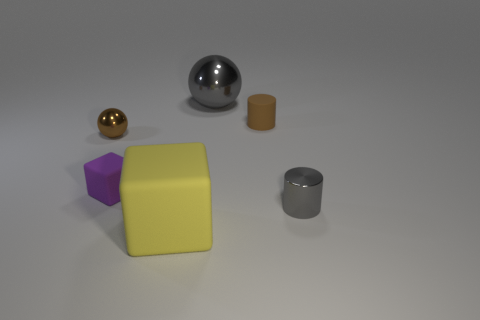What number of metallic spheres have the same size as the purple rubber block?
Ensure brevity in your answer.  1. What number of small gray metallic cylinders are behind the tiny purple block that is left of the large gray ball?
Give a very brief answer. 0. Is the color of the metallic object that is left of the big yellow matte cube the same as the large block?
Keep it short and to the point. No. There is a gray metallic object that is behind the cube that is behind the small gray metallic thing; is there a tiny object left of it?
Provide a short and direct response. Yes. There is a shiny object that is both behind the tiny block and to the right of the purple object; what is its shape?
Your response must be concise. Sphere. Is there a small matte block that has the same color as the large cube?
Provide a short and direct response. No. The ball that is right of the rubber block that is in front of the shiny cylinder is what color?
Give a very brief answer. Gray. There is a matte thing that is on the right side of the big object behind the metal thing that is right of the rubber cylinder; what size is it?
Keep it short and to the point. Small. Do the large gray thing and the block behind the big block have the same material?
Your answer should be very brief. No. What is the size of the brown thing that is made of the same material as the large gray ball?
Offer a very short reply. Small. 